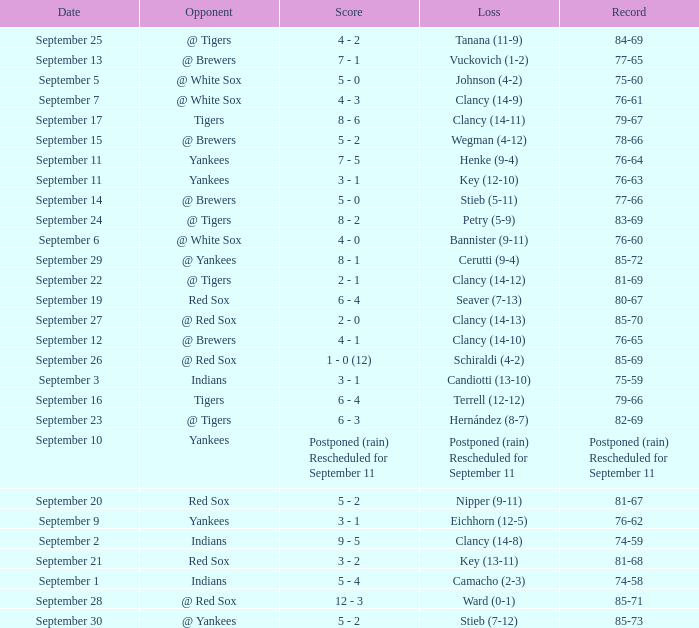Who was the Blue Jays opponent when their record was 84-69? @ Tigers. 